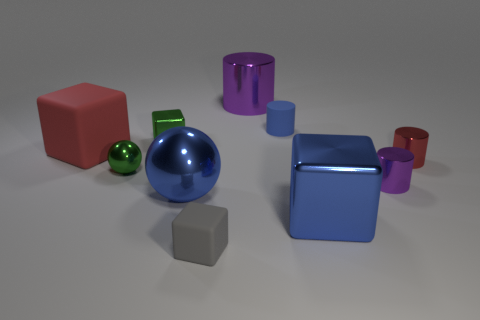Subtract all brown cubes. Subtract all yellow spheres. How many cubes are left? 4 Subtract all cylinders. How many objects are left? 6 Subtract 0 gray spheres. How many objects are left? 10 Subtract all big metal blocks. Subtract all small gray blocks. How many objects are left? 8 Add 5 big cubes. How many big cubes are left? 7 Add 7 big matte things. How many big matte things exist? 8 